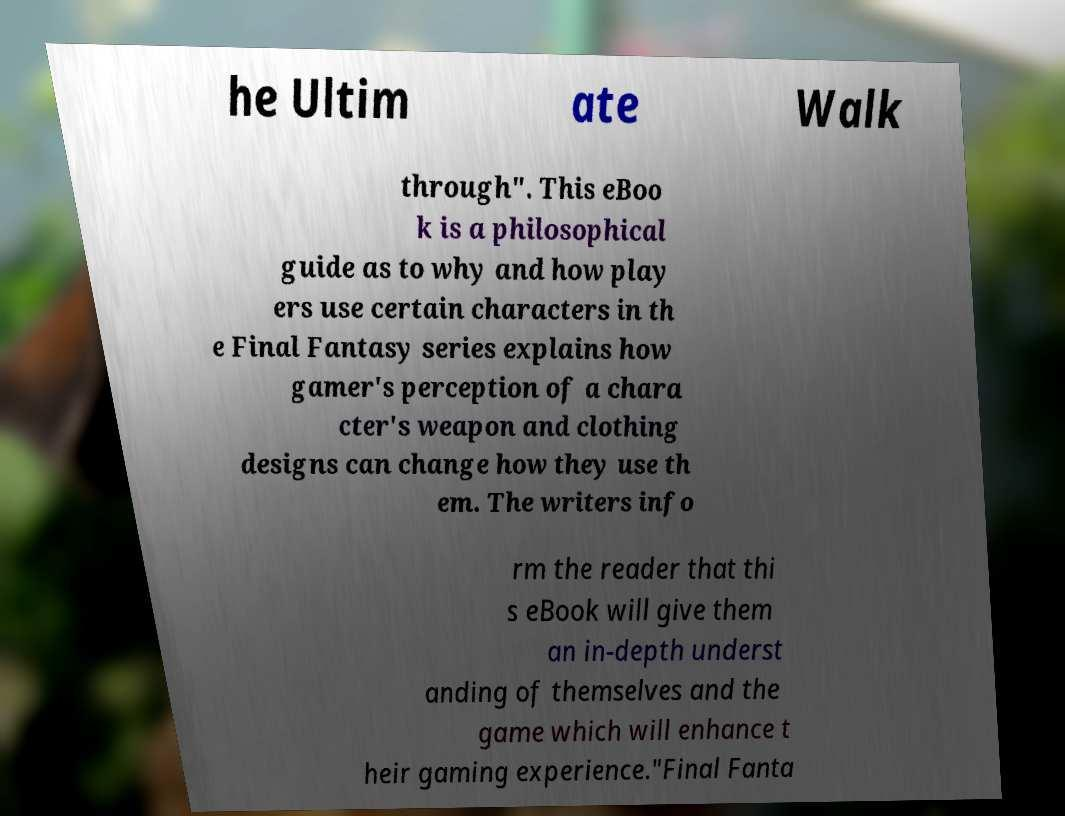For documentation purposes, I need the text within this image transcribed. Could you provide that? he Ultim ate Walk through". This eBoo k is a philosophical guide as to why and how play ers use certain characters in th e Final Fantasy series explains how gamer's perception of a chara cter's weapon and clothing designs can change how they use th em. The writers info rm the reader that thi s eBook will give them an in-depth underst anding of themselves and the game which will enhance t heir gaming experience."Final Fanta 